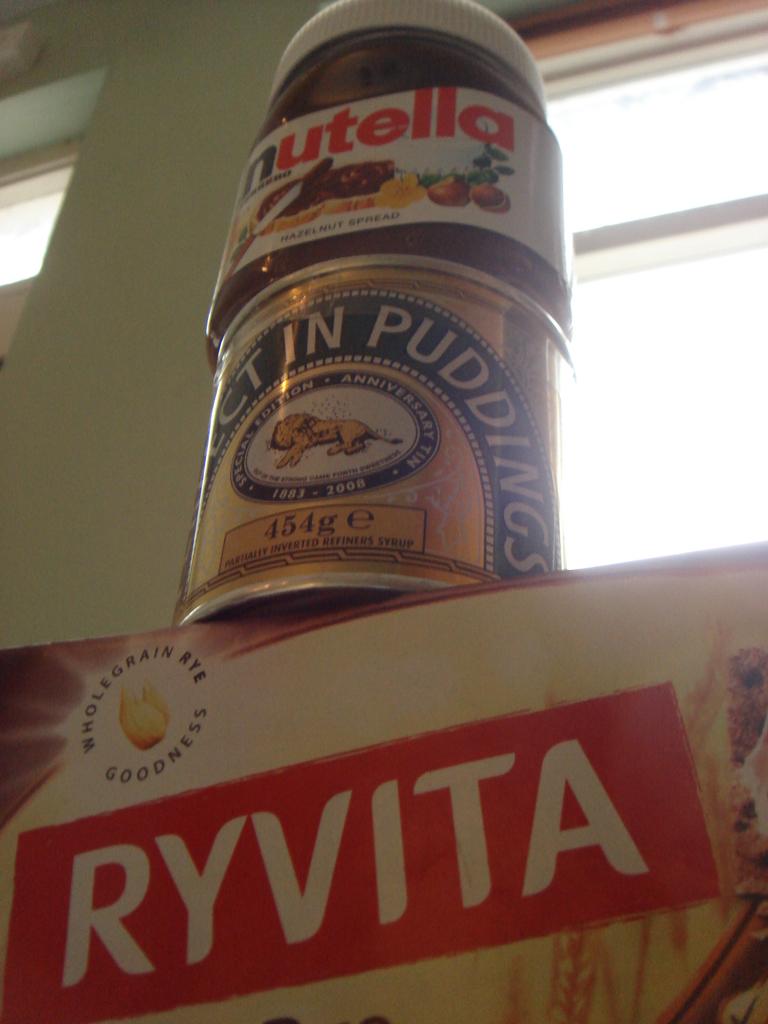What is the brand on the bottom box?
Your answer should be very brief. Ryvita. 